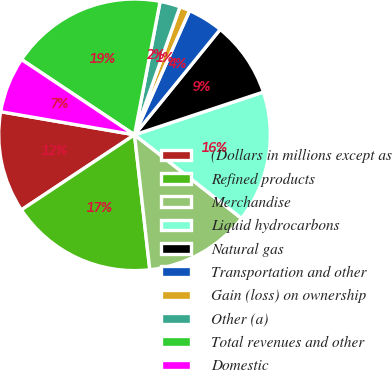<chart> <loc_0><loc_0><loc_500><loc_500><pie_chart><fcel>(Dollars in millions except as<fcel>Refined products<fcel>Merchandise<fcel>Liquid hydrocarbons<fcel>Natural gas<fcel>Transportation and other<fcel>Gain (loss) on ownership<fcel>Other (a)<fcel>Total revenues and other<fcel>Domestic<nl><fcel>12.05%<fcel>17.47%<fcel>12.65%<fcel>15.66%<fcel>9.04%<fcel>4.22%<fcel>1.21%<fcel>2.41%<fcel>18.67%<fcel>6.63%<nl></chart> 